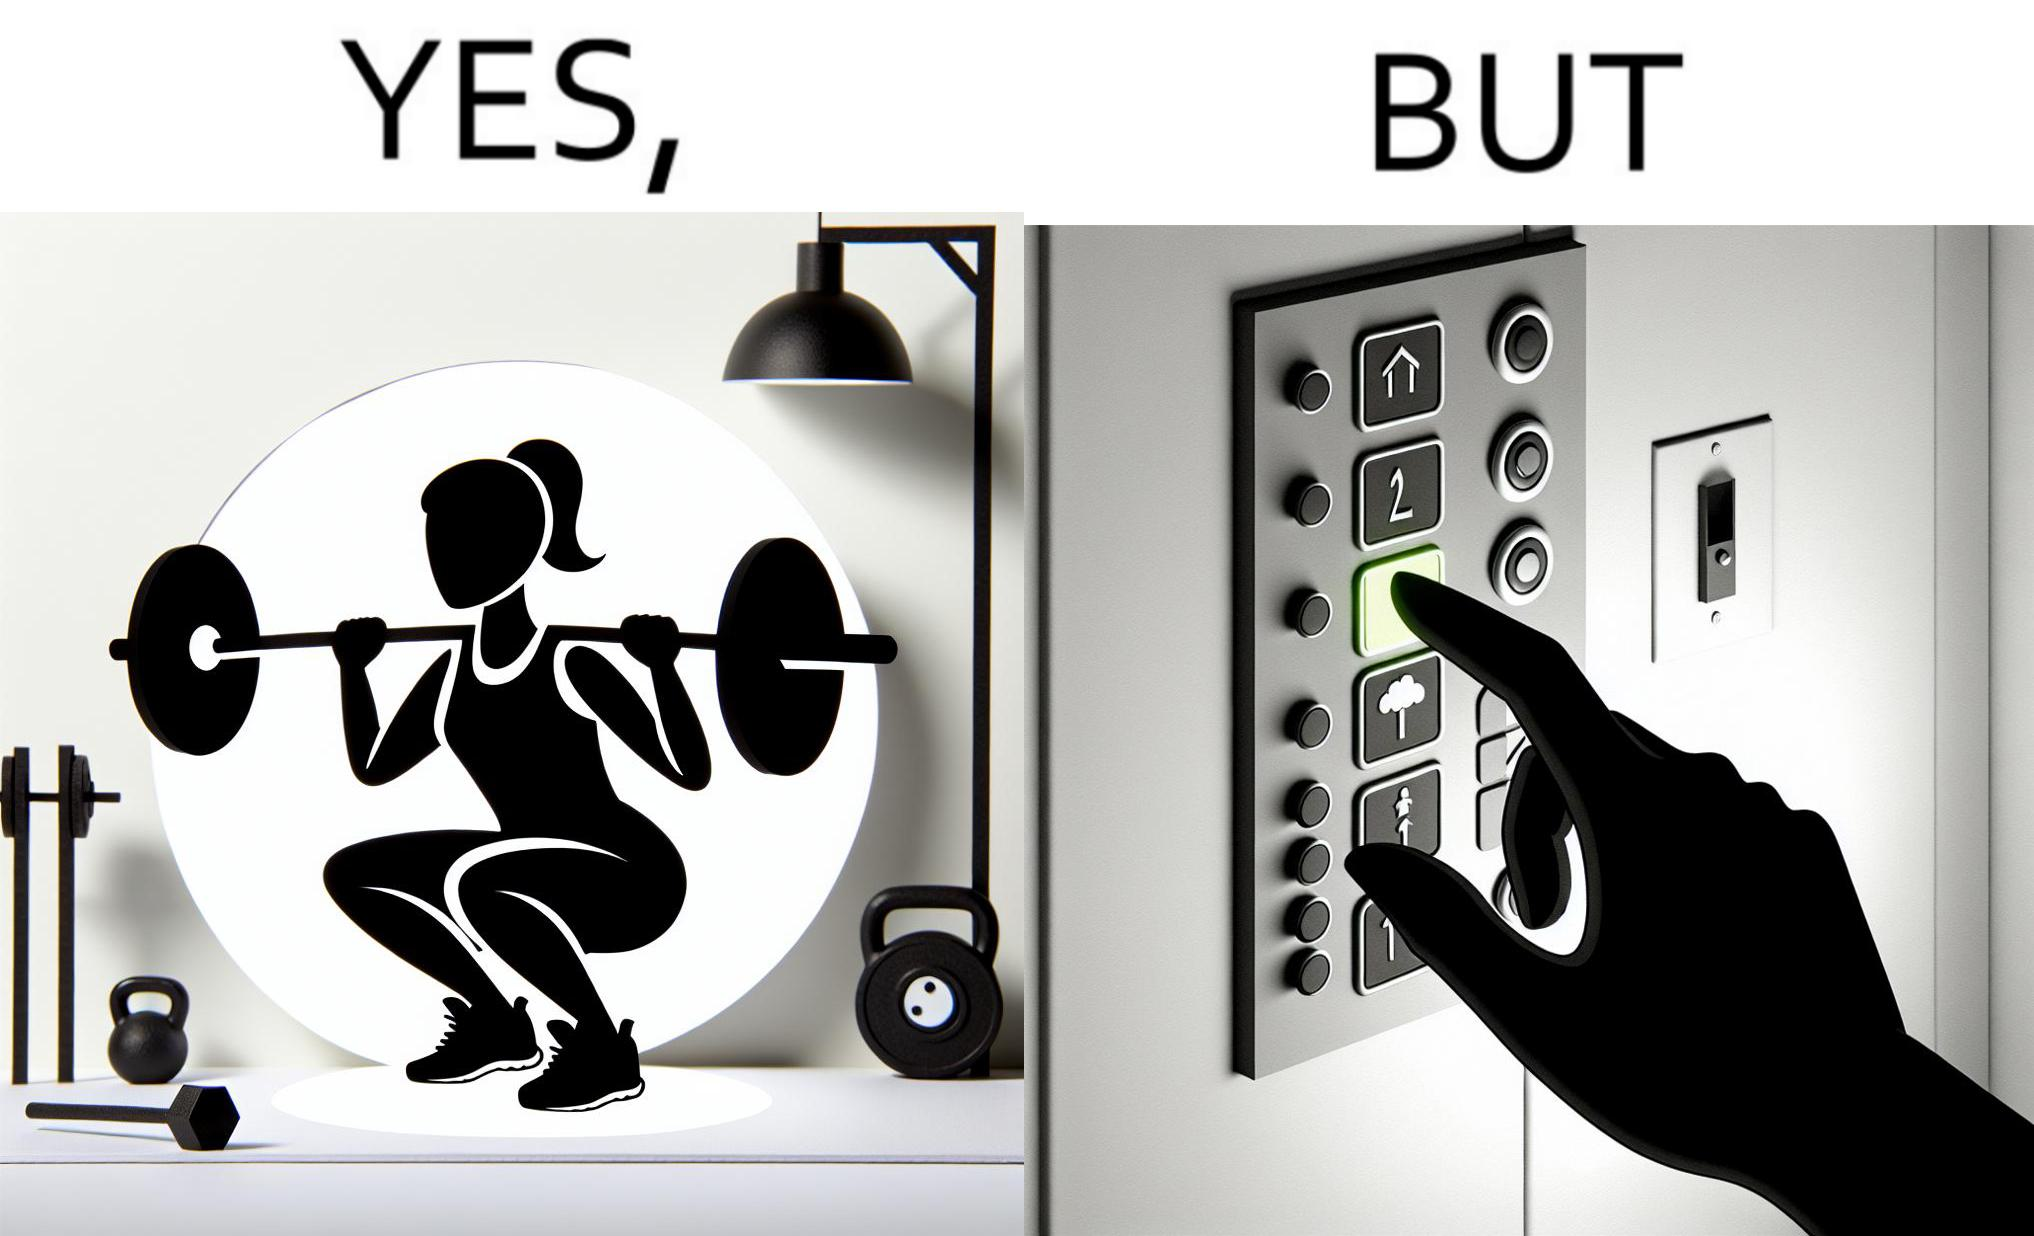Provide a description of this image. The image is satirical because it shows that while people do various kinds of exercises and go to gym to stay fit, they avoid doing simplest of physical tasks like using stairs instead of elevators to get to even the first or the second floor of a building. 